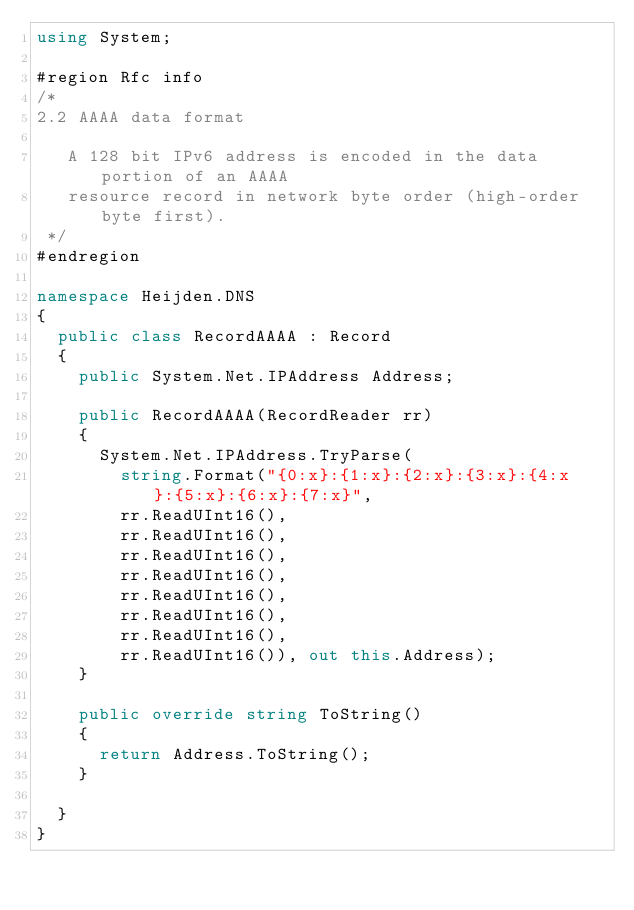Convert code to text. <code><loc_0><loc_0><loc_500><loc_500><_C#_>using System;

#region Rfc info
/*
2.2 AAAA data format

   A 128 bit IPv6 address is encoded in the data portion of an AAAA
   resource record in network byte order (high-order byte first).
 */
#endregion

namespace Heijden.DNS
{
	public class RecordAAAA : Record
	{
		public System.Net.IPAddress Address;

		public RecordAAAA(RecordReader rr)
		{
			System.Net.IPAddress.TryParse(
				string.Format("{0:x}:{1:x}:{2:x}:{3:x}:{4:x}:{5:x}:{6:x}:{7:x}",
				rr.ReadUInt16(),
				rr.ReadUInt16(),
				rr.ReadUInt16(),
				rr.ReadUInt16(),
				rr.ReadUInt16(),
				rr.ReadUInt16(),
				rr.ReadUInt16(),
				rr.ReadUInt16()), out this.Address);
		}

		public override string ToString()
		{
			return Address.ToString();
		}

	}
}
</code> 